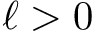<formula> <loc_0><loc_0><loc_500><loc_500>\ell > 0</formula> 